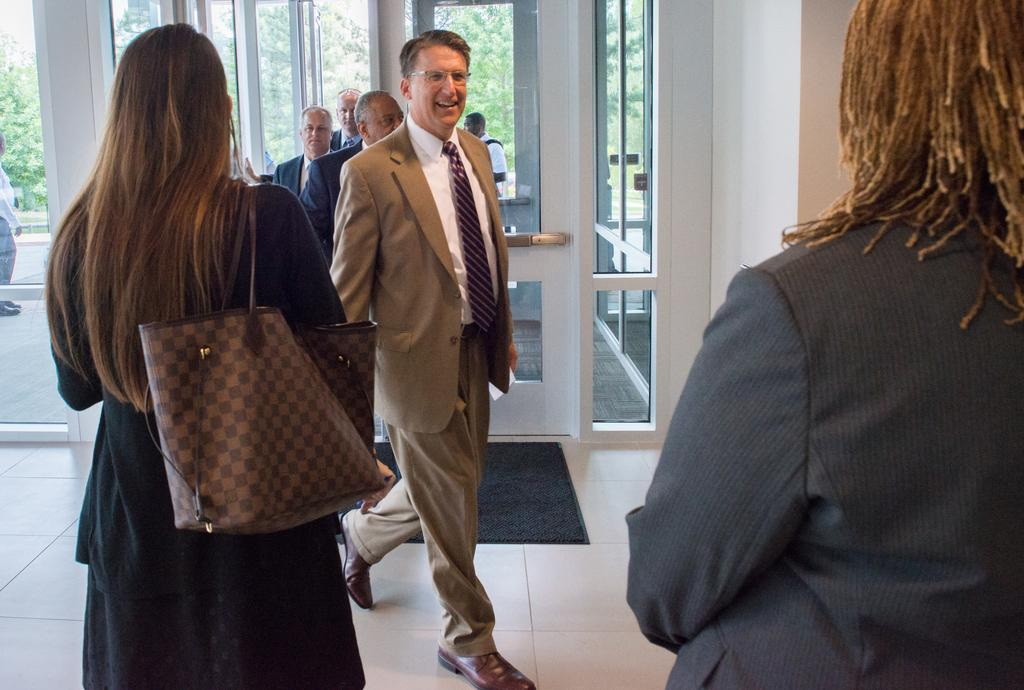What are the people in the image doing? There are persons standing and walking in the image. What can be seen on the floor in the image? The floor is visible in the image. What is located near the entrance in the image? There is a doormat in the image. What type of doors are present in the image? Glass doors are present in the image. What is visible through the glass doors? Trees and persons are visible outside through the glass doors. How many rabbits can be seen hopping on the doormat in the image? There are no rabbits present in the image; only persons, a doormat, and glass doors are visible. 